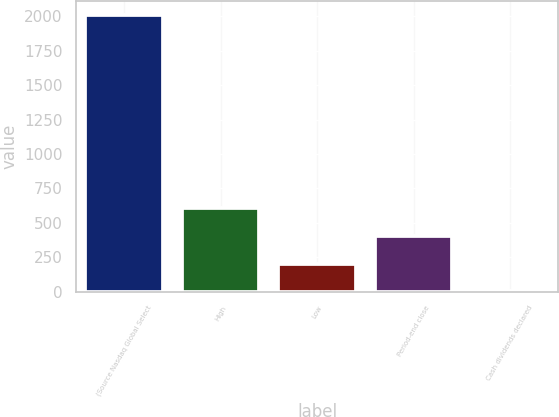Convert chart. <chart><loc_0><loc_0><loc_500><loc_500><bar_chart><fcel>(Source Nasdaq Global Select<fcel>High<fcel>Low<fcel>Period-end close<fcel>Cash dividends declared<nl><fcel>2013<fcel>604.19<fcel>201.67<fcel>402.93<fcel>0.41<nl></chart> 